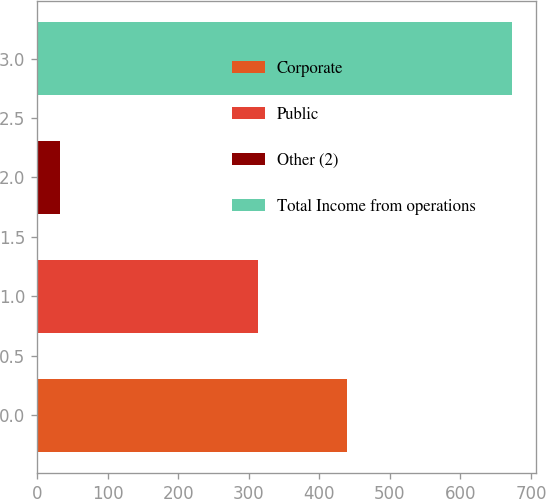Convert chart to OTSL. <chart><loc_0><loc_0><loc_500><loc_500><bar_chart><fcel>Corporate<fcel>Public<fcel>Other (2)<fcel>Total Income from operations<nl><fcel>439.8<fcel>313.2<fcel>32.9<fcel>673<nl></chart> 